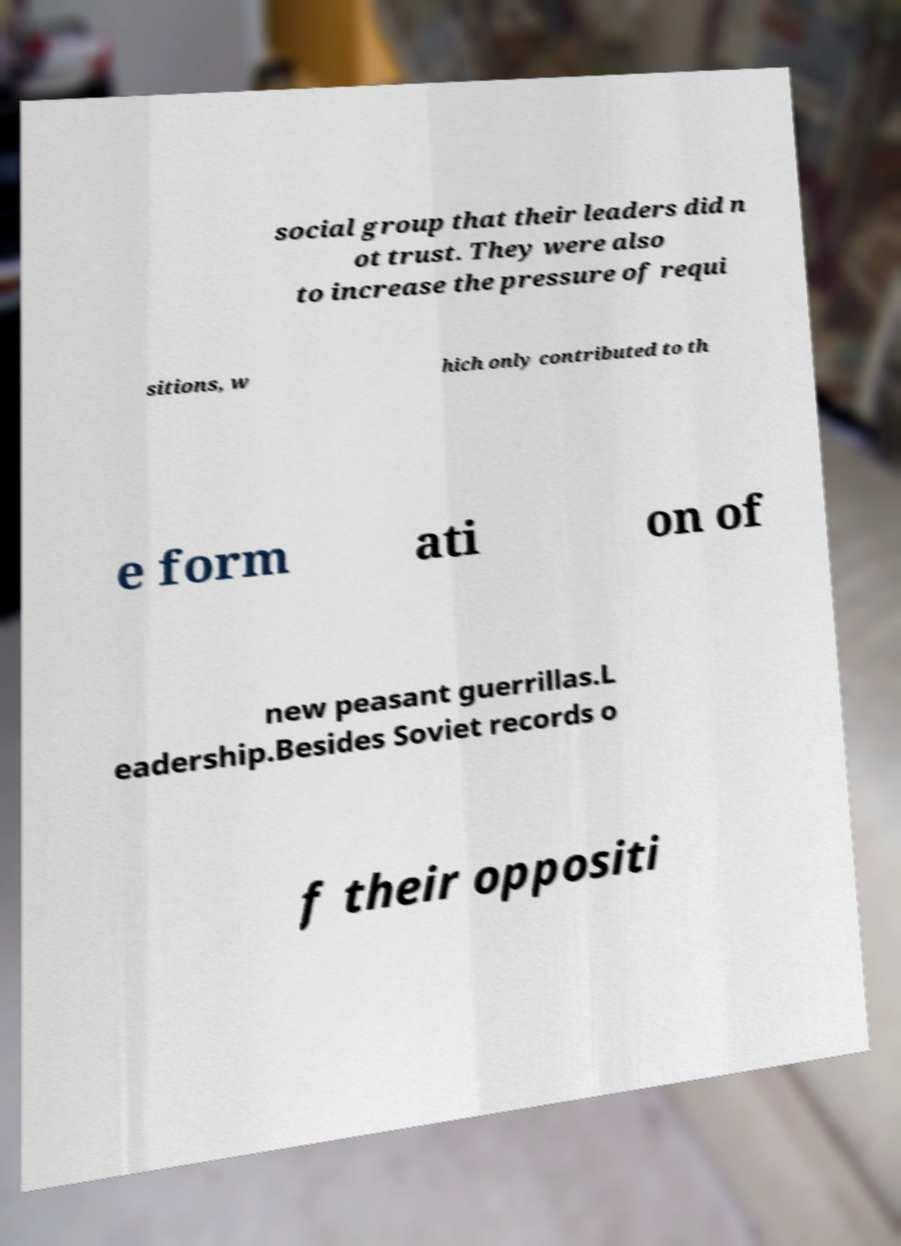Can you read and provide the text displayed in the image?This photo seems to have some interesting text. Can you extract and type it out for me? social group that their leaders did n ot trust. They were also to increase the pressure of requi sitions, w hich only contributed to th e form ati on of new peasant guerrillas.L eadership.Besides Soviet records o f their oppositi 